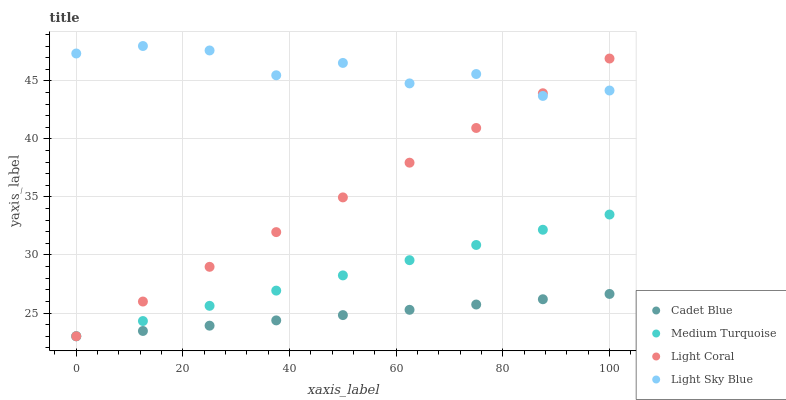Does Cadet Blue have the minimum area under the curve?
Answer yes or no. Yes. Does Light Sky Blue have the maximum area under the curve?
Answer yes or no. Yes. Does Medium Turquoise have the minimum area under the curve?
Answer yes or no. No. Does Medium Turquoise have the maximum area under the curve?
Answer yes or no. No. Is Cadet Blue the smoothest?
Answer yes or no. Yes. Is Light Sky Blue the roughest?
Answer yes or no. Yes. Is Medium Turquoise the smoothest?
Answer yes or no. No. Is Medium Turquoise the roughest?
Answer yes or no. No. Does Light Coral have the lowest value?
Answer yes or no. Yes. Does Light Sky Blue have the lowest value?
Answer yes or no. No. Does Light Sky Blue have the highest value?
Answer yes or no. Yes. Does Medium Turquoise have the highest value?
Answer yes or no. No. Is Cadet Blue less than Light Sky Blue?
Answer yes or no. Yes. Is Light Sky Blue greater than Medium Turquoise?
Answer yes or no. Yes. Does Cadet Blue intersect Light Coral?
Answer yes or no. Yes. Is Cadet Blue less than Light Coral?
Answer yes or no. No. Is Cadet Blue greater than Light Coral?
Answer yes or no. No. Does Cadet Blue intersect Light Sky Blue?
Answer yes or no. No. 